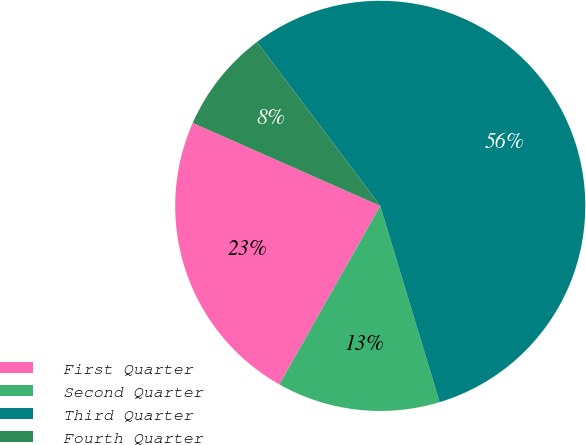<chart> <loc_0><loc_0><loc_500><loc_500><pie_chart><fcel>First Quarter<fcel>Second Quarter<fcel>Third Quarter<fcel>Fourth Quarter<nl><fcel>23.44%<fcel>12.86%<fcel>55.58%<fcel>8.11%<nl></chart> 